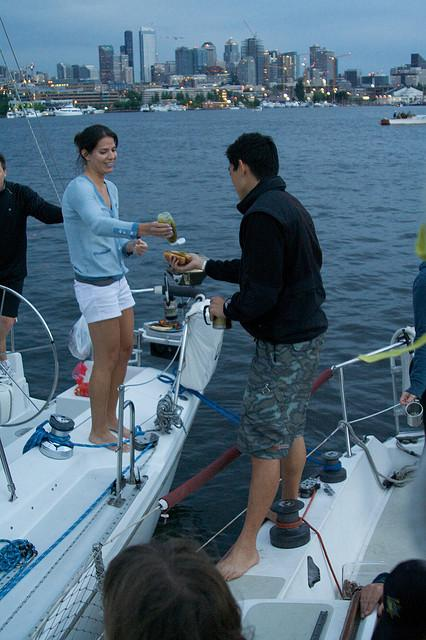What kind of sauce is this? relish 